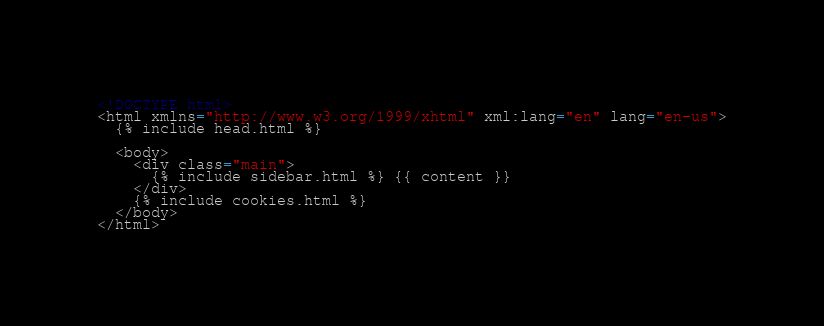<code> <loc_0><loc_0><loc_500><loc_500><_HTML_><!DOCTYPE html>
<html xmlns="http://www.w3.org/1999/xhtml" xml:lang="en" lang="en-us">
  {% include head.html %}

  <body>
    <div class="main">
      {% include sidebar.html %} {{ content }}
    </div>
    {% include cookies.html %}
  </body>
</html>
</code> 